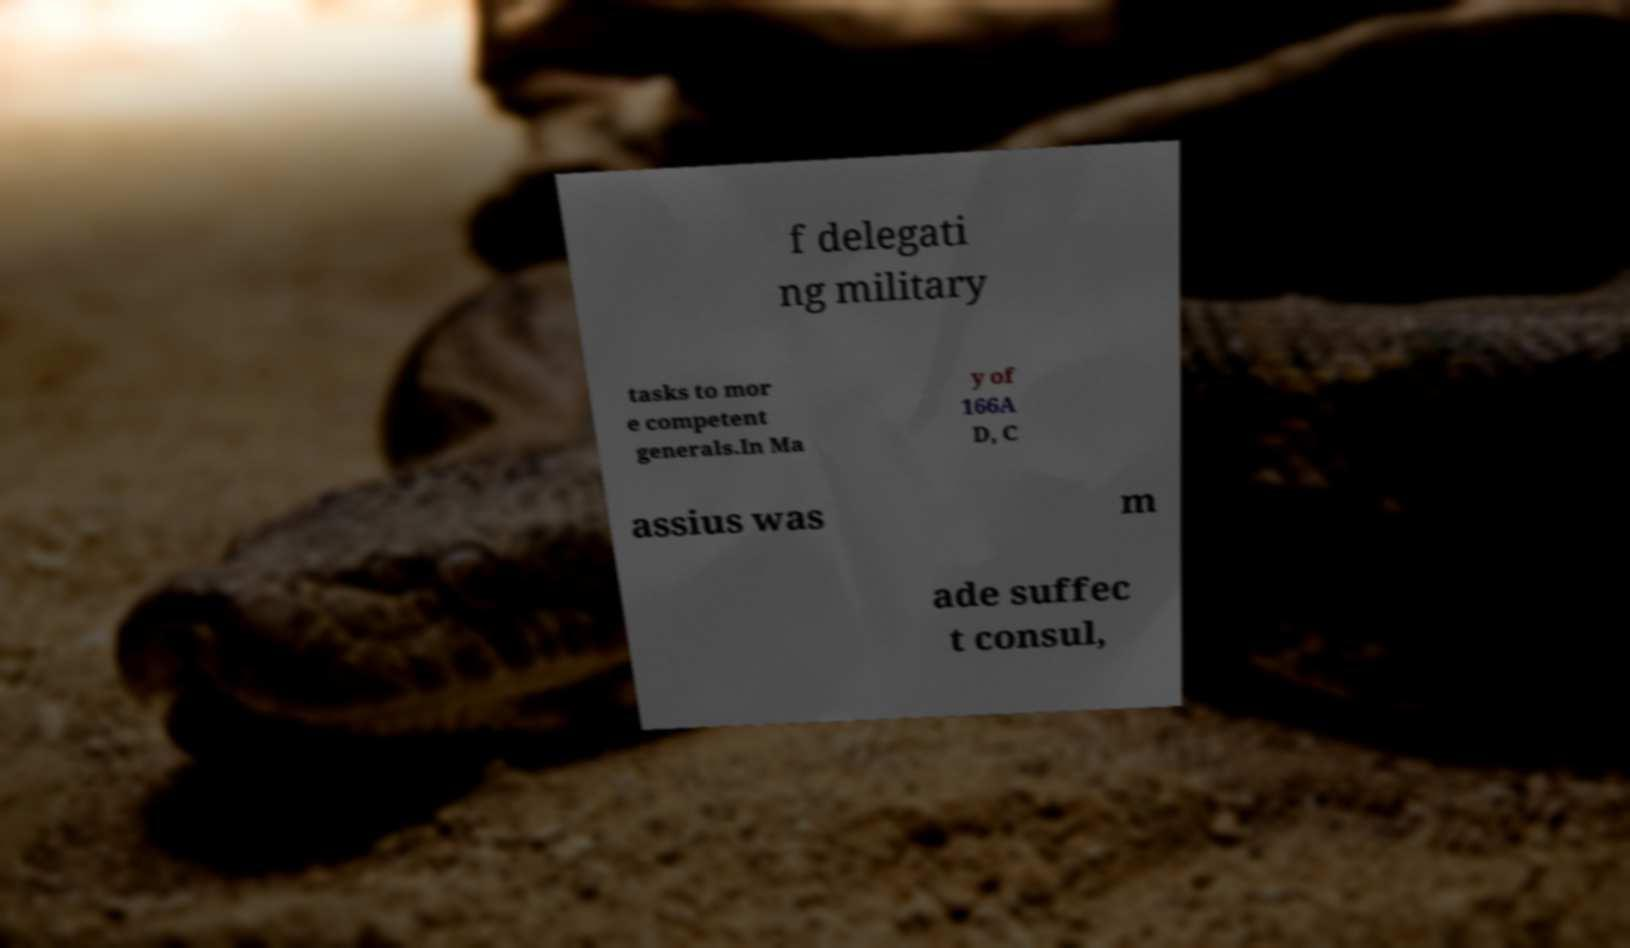Please identify and transcribe the text found in this image. f delegati ng military tasks to mor e competent generals.In Ma y of 166A D, C assius was m ade suffec t consul, 